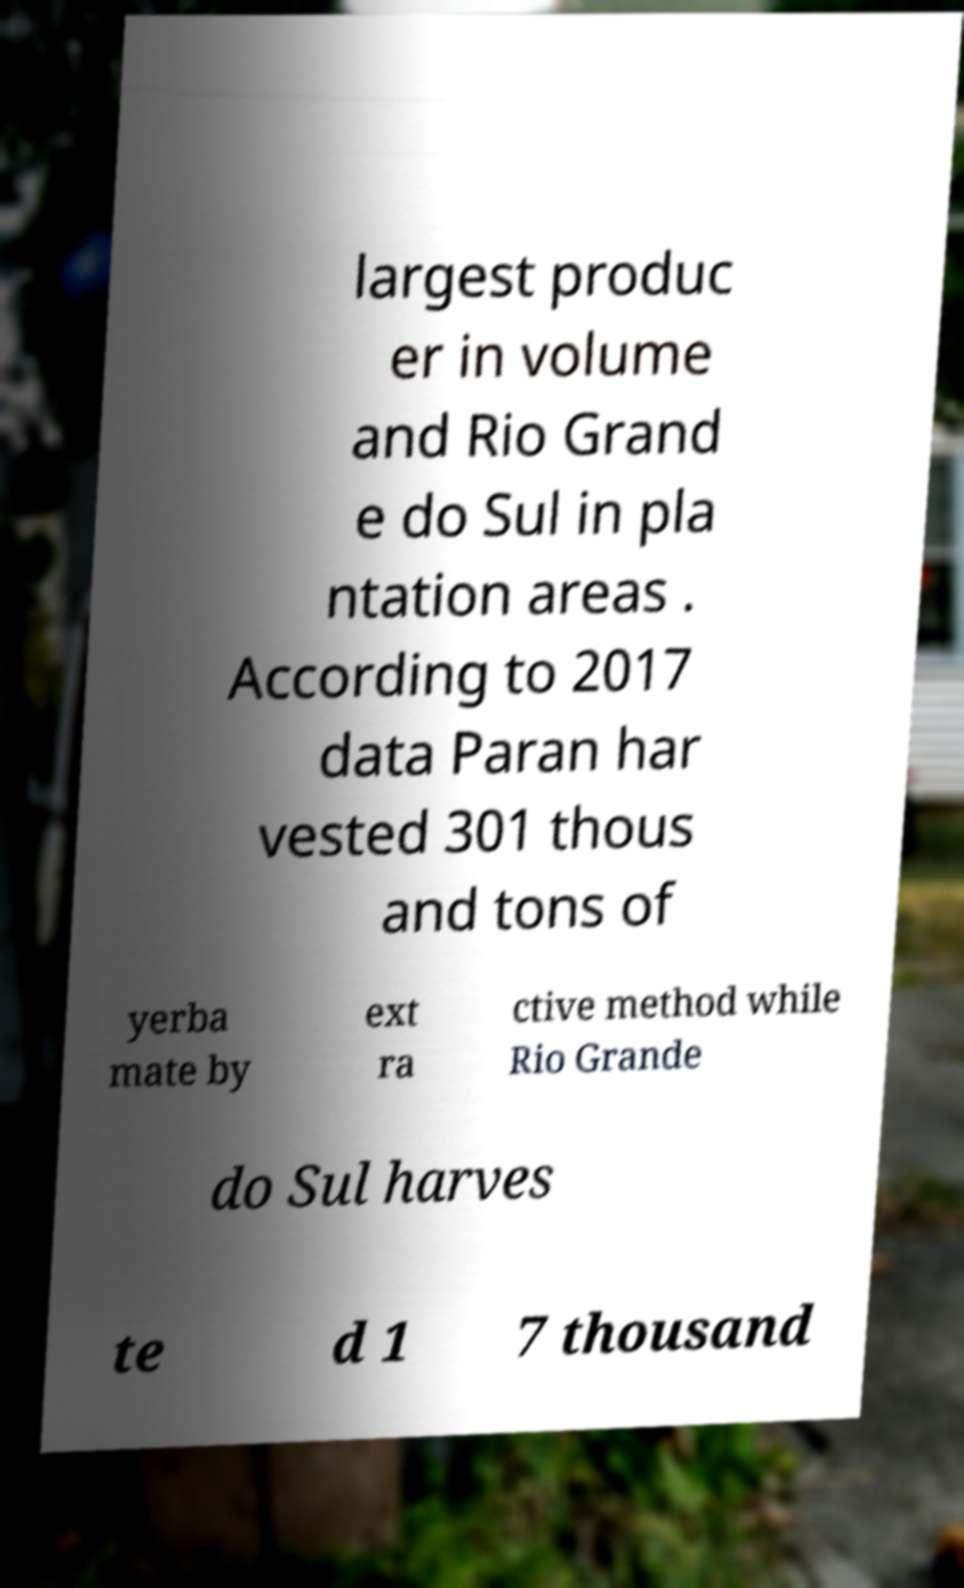Can you accurately transcribe the text from the provided image for me? largest produc er in volume and Rio Grand e do Sul in pla ntation areas . According to 2017 data Paran har vested 301 thous and tons of yerba mate by ext ra ctive method while Rio Grande do Sul harves te d 1 7 thousand 